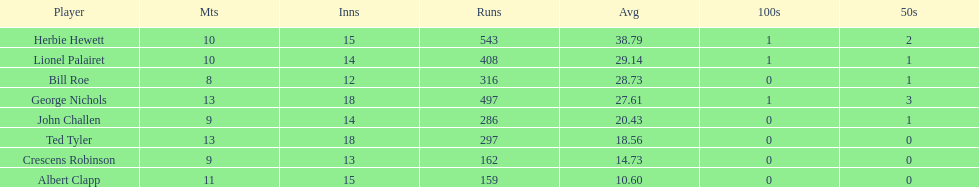What was the total number of innings played by bill and ted? 30. 